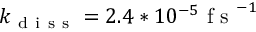<formula> <loc_0><loc_0><loc_500><loc_500>k _ { d i s s } = 2 . 4 * 1 0 ^ { - 5 } f s ^ { - 1 }</formula> 